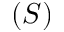Convert formula to latex. <formula><loc_0><loc_0><loc_500><loc_500>( S )</formula> 